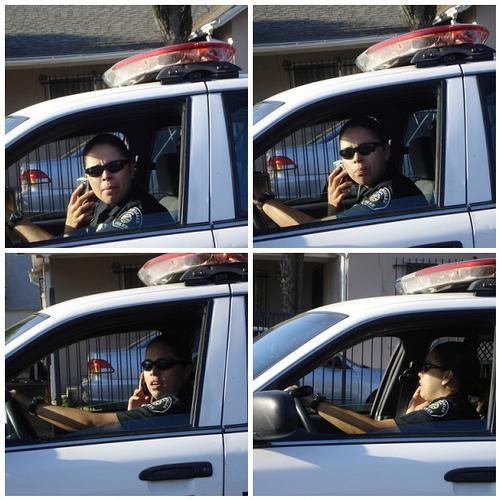List the principal components of this scene and describe the activities the police officers are involved in. Principal components include police officers, cars, door handles, side windows, and emergency lights. The police officers are talking on their phones or driving their cars. Describe the primary subject of this image and their actions, along with any important objects in the scene. The primary subject is police officers inside their cars, participating in various activities like talking on the phone and driving, with notable objects such as emergency lights and door handles. What is the main action happening in this image, and what are some key visible features? The main action centers around police officers inside cars who are on their phones or driving, with visible features including door handles, side windows, and emergency lights. Summarize the scenario captured in this image, including the main characters, their actions, and any relevant objects. The scenario features police officers in cars who are on the phone or driving, with relevant objects such as door handles, side windows, and emergency lights captured in the image. Give a short summary of the key elements and actions happening in the image. In this image, multiple police officers are inside their cars, engaging in various activities such as talking on the phone and driving, with emergency lights and car handles visible. Briefly describe this scene including details about the subject and any prevalent objects. The scene shows a police officer inside a car with various visible elements such as the side window, door handle, red and white emergency lights, as well as a cop in another car. What is the primary focus of this scene and what are the officers doing? The primary focus is on police officers within their cars and they are on their phones or driving, with other specific details like emergency lights, car handles, and side windows. Can you provide a quick summary of what's happening in the image, including any notable objects or actions? The image features multiple police officers in cars who are either on their phones or driving, with additional elements like door handles, side windows, and emergency lights present. In a few sentences, explain what's going on in this picture, with a focus on the officers and any interesting objects or details. In the picture, several police officers are engaged in various activities within their cars, such as talking on the phone and driving, with interesting details like emergency lights and door handles visible. What are the main objects visible in this picture and what are the police officers doing? Main objects visible include police officers, cars, side windows, door handles, emergency lights, and the police officers are on their phones or driving the cars. Is the police officer wearing a blue hat in the image? There is no information given about a blue hat worn by the police officer, making this instruction misleading. Can you identify the green tree reflected in the car's side window? No, it's not mentioned in the image. Can you find the orange traffic cone placed near the car's rear tire? There is no information given about an orange traffic cone in the image, making this instruction misleading. Can you spot the gray cat sitting on the hood of the car? There is no mention of a gray cat or any animal in the provided information, making this instruction misleading. Is the car parked next to a yellow fire hydrant? There is no information given about a yellow fire hydrant in the image, making this instruction misleading. Is the man in the car holding an umbrella in his left hand? There is no mention of an umbrella being held by the man in the car, making this instruction misleading. 